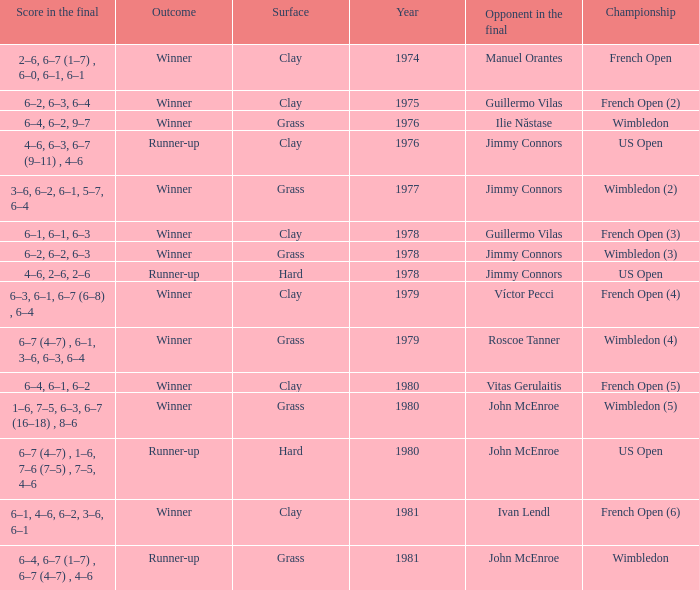What is every surface with a score in the final of 6–4, 6–7 (1–7) , 6–7 (4–7) , 4–6? Grass. 